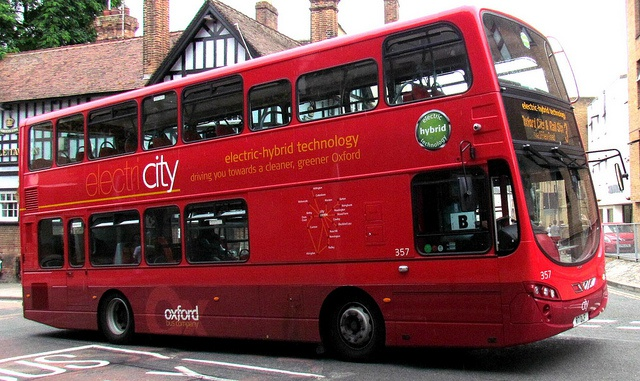Describe the objects in this image and their specific colors. I can see bus in darkgreen, brown, black, and maroon tones, car in darkgreen, darkgray, lightpink, lavender, and gray tones, people in darkgreen, black, and gray tones, people in darkgreen, gray, black, and maroon tones, and people in darkgreen, darkgray, gray, and lightgray tones in this image. 